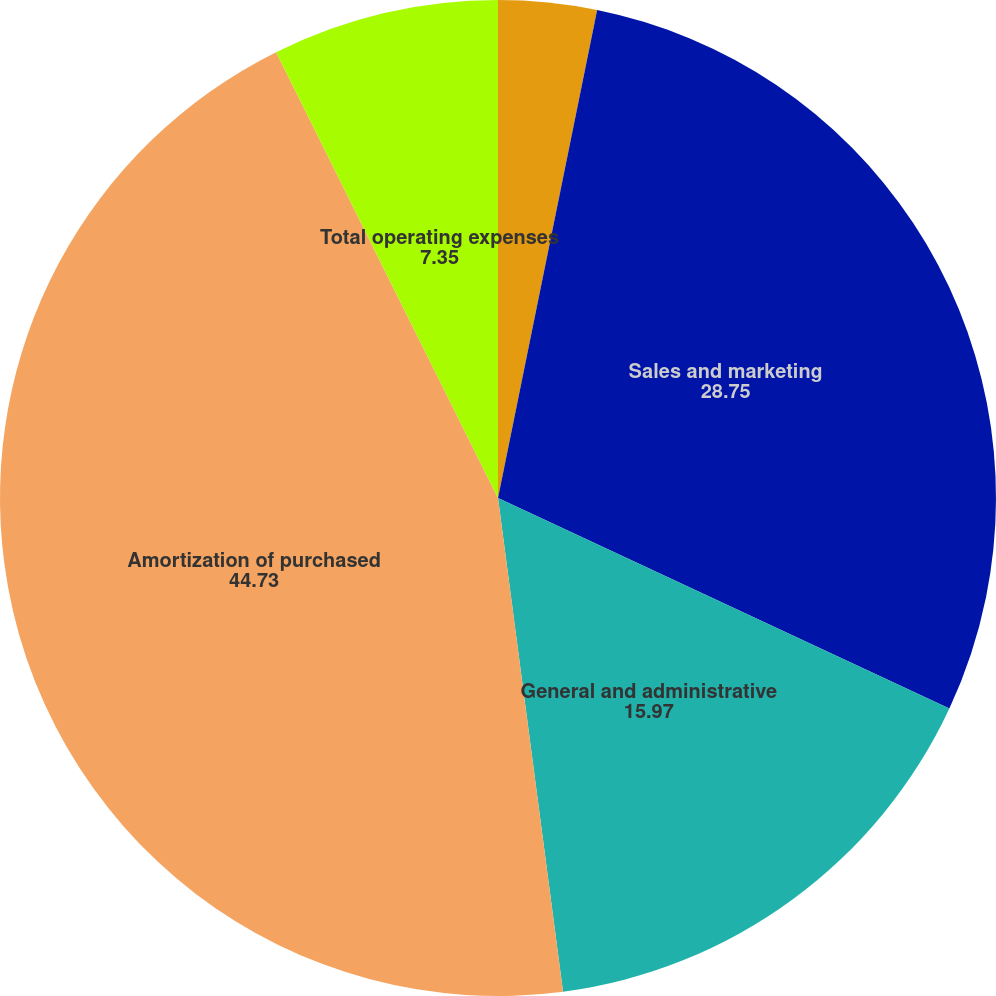Convert chart to OTSL. <chart><loc_0><loc_0><loc_500><loc_500><pie_chart><fcel>Research and development<fcel>Sales and marketing<fcel>General and administrative<fcel>Amortization of purchased<fcel>Total operating expenses<nl><fcel>3.19%<fcel>28.75%<fcel>15.97%<fcel>44.73%<fcel>7.35%<nl></chart> 